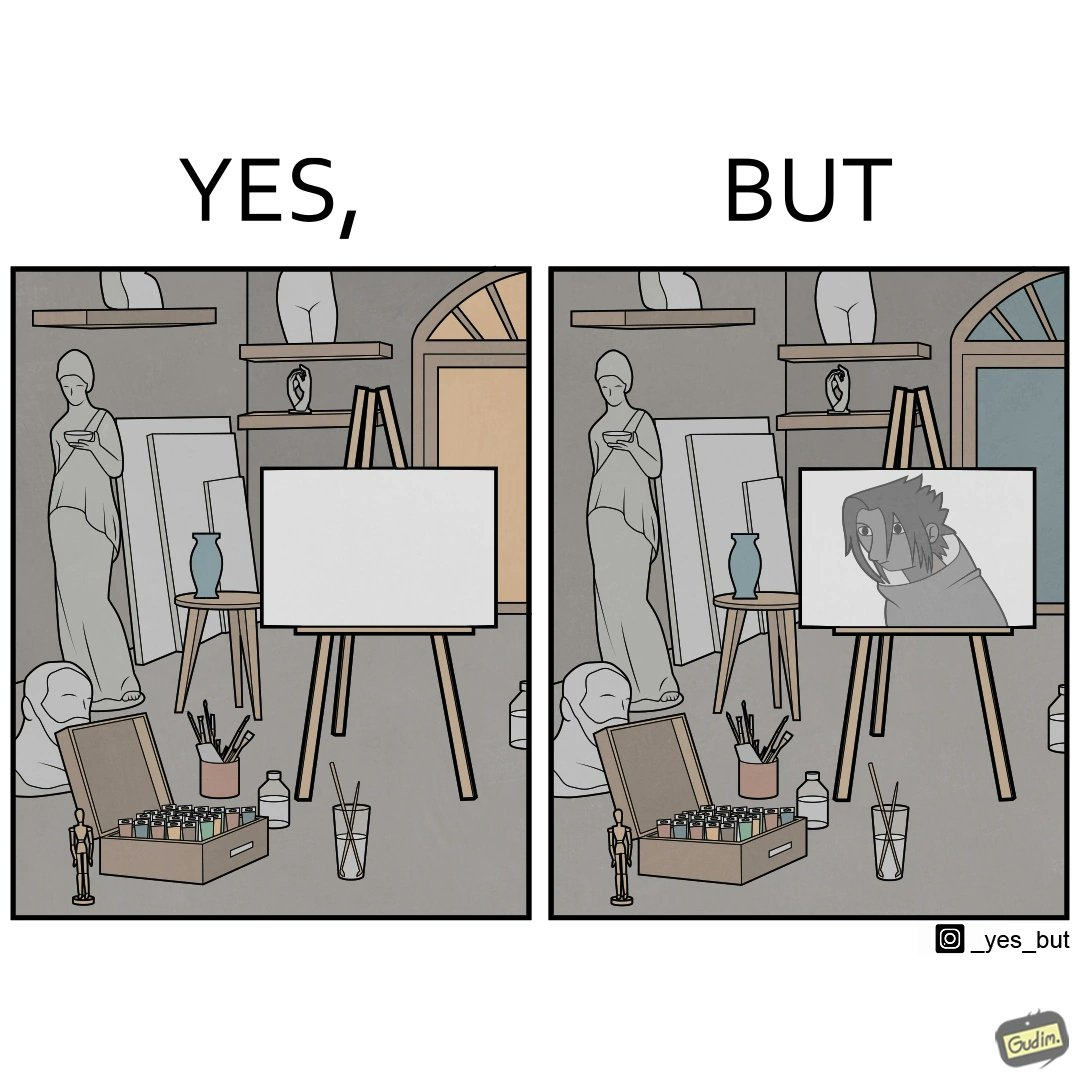What makes this image funny or satirical? The image is ironical, as even though the art studio contains a palette of a range of color paints, the painting on the canvas is black and white. 